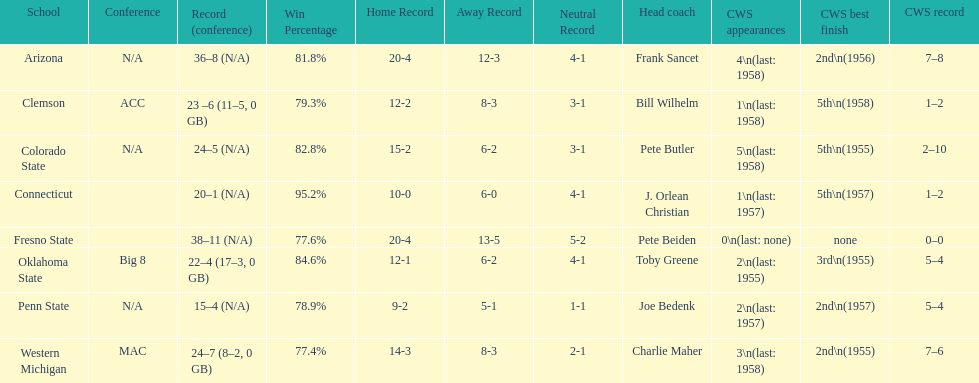Which school has no cws appearances? Fresno State. 